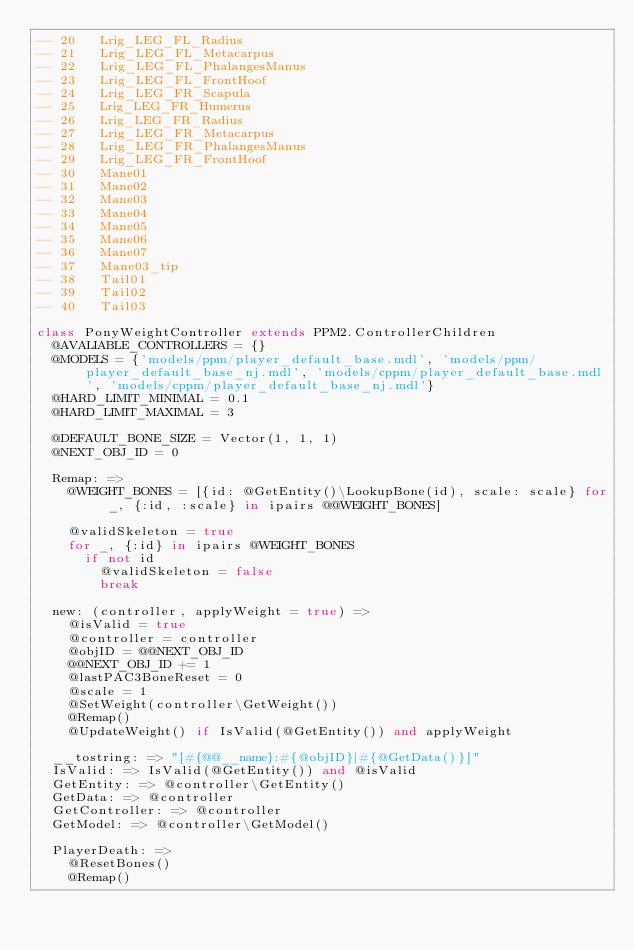Convert code to text. <code><loc_0><loc_0><loc_500><loc_500><_MoonScript_>-- 20   Lrig_LEG_FL_Radius
-- 21   Lrig_LEG_FL_Metacarpus
-- 22   Lrig_LEG_FL_PhalangesManus
-- 23   Lrig_LEG_FL_FrontHoof
-- 24   Lrig_LEG_FR_Scapula
-- 25   Lrig_LEG_FR_Humerus
-- 26   Lrig_LEG_FR_Radius
-- 27   Lrig_LEG_FR_Metacarpus
-- 28   Lrig_LEG_FR_PhalangesManus
-- 29   Lrig_LEG_FR_FrontHoof
-- 30   Mane01
-- 31   Mane02
-- 32   Mane03
-- 33   Mane04
-- 34   Mane05
-- 35   Mane06
-- 36   Mane07
-- 37   Mane03_tip
-- 38   Tail01
-- 39   Tail02
-- 40   Tail03

class PonyWeightController extends PPM2.ControllerChildren
	@AVALIABLE_CONTROLLERS = {}
	@MODELS = {'models/ppm/player_default_base.mdl', 'models/ppm/player_default_base_nj.mdl', 'models/cppm/player_default_base.mdl', 'models/cppm/player_default_base_nj.mdl'}
	@HARD_LIMIT_MINIMAL = 0.1
	@HARD_LIMIT_MAXIMAL = 3

	@DEFAULT_BONE_SIZE = Vector(1, 1, 1)
	@NEXT_OBJ_ID = 0

	Remap: =>
		@WEIGHT_BONES = [{id: @GetEntity()\LookupBone(id), scale: scale} for _, {:id, :scale} in ipairs @@WEIGHT_BONES]

		@validSkeleton = true
		for _, {:id} in ipairs @WEIGHT_BONES
			if not id
				@validSkeleton = false
				break

	new: (controller, applyWeight = true) =>
		@isValid = true
		@controller = controller
		@objID = @@NEXT_OBJ_ID
		@@NEXT_OBJ_ID += 1
		@lastPAC3BoneReset = 0
		@scale = 1
		@SetWeight(controller\GetWeight())
		@Remap()
		@UpdateWeight() if IsValid(@GetEntity()) and applyWeight

	__tostring: => "[#{@@__name}:#{@objID}|#{@GetData()}]"
	IsValid: => IsValid(@GetEntity()) and @isValid
	GetEntity: => @controller\GetEntity()
	GetData: => @controller
	GetController: => @controller
	GetModel: => @controller\GetModel()

	PlayerDeath: =>
		@ResetBones()
		@Remap()
</code> 